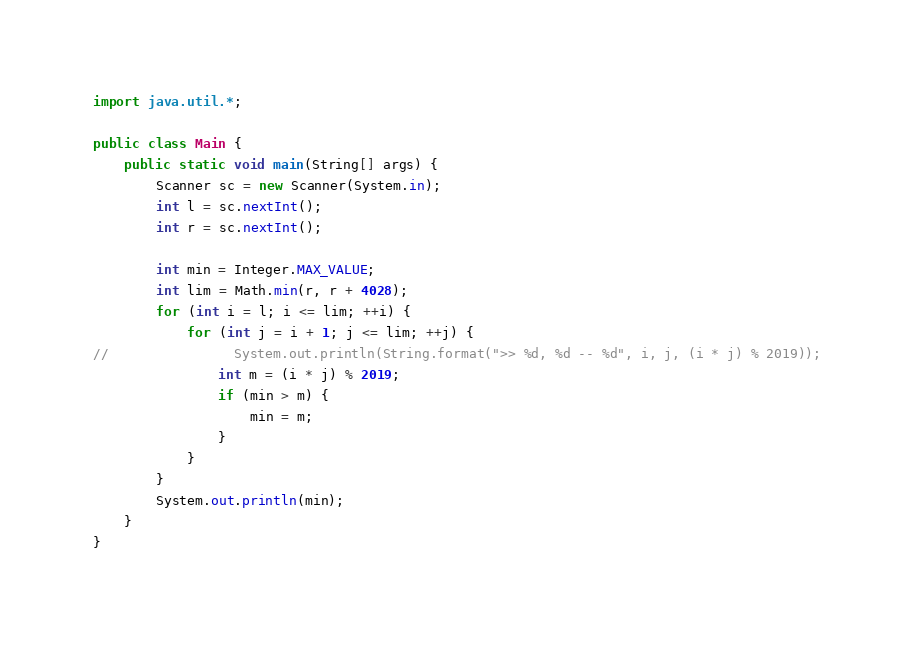Convert code to text. <code><loc_0><loc_0><loc_500><loc_500><_Java_>import java.util.*;

public class Main {
    public static void main(String[] args) {
        Scanner sc = new Scanner(System.in);
        int l = sc.nextInt();
        int r = sc.nextInt();

        int min = Integer.MAX_VALUE;
        int lim = Math.min(r, r + 4028);
        for (int i = l; i <= lim; ++i) {
            for (int j = i + 1; j <= lim; ++j) {
//                System.out.println(String.format(">> %d, %d -- %d", i, j, (i * j) % 2019));
                int m = (i * j) % 2019;
                if (min > m) {
                    min = m;
                }
            }
        }
        System.out.println(min);
    }
}

</code> 